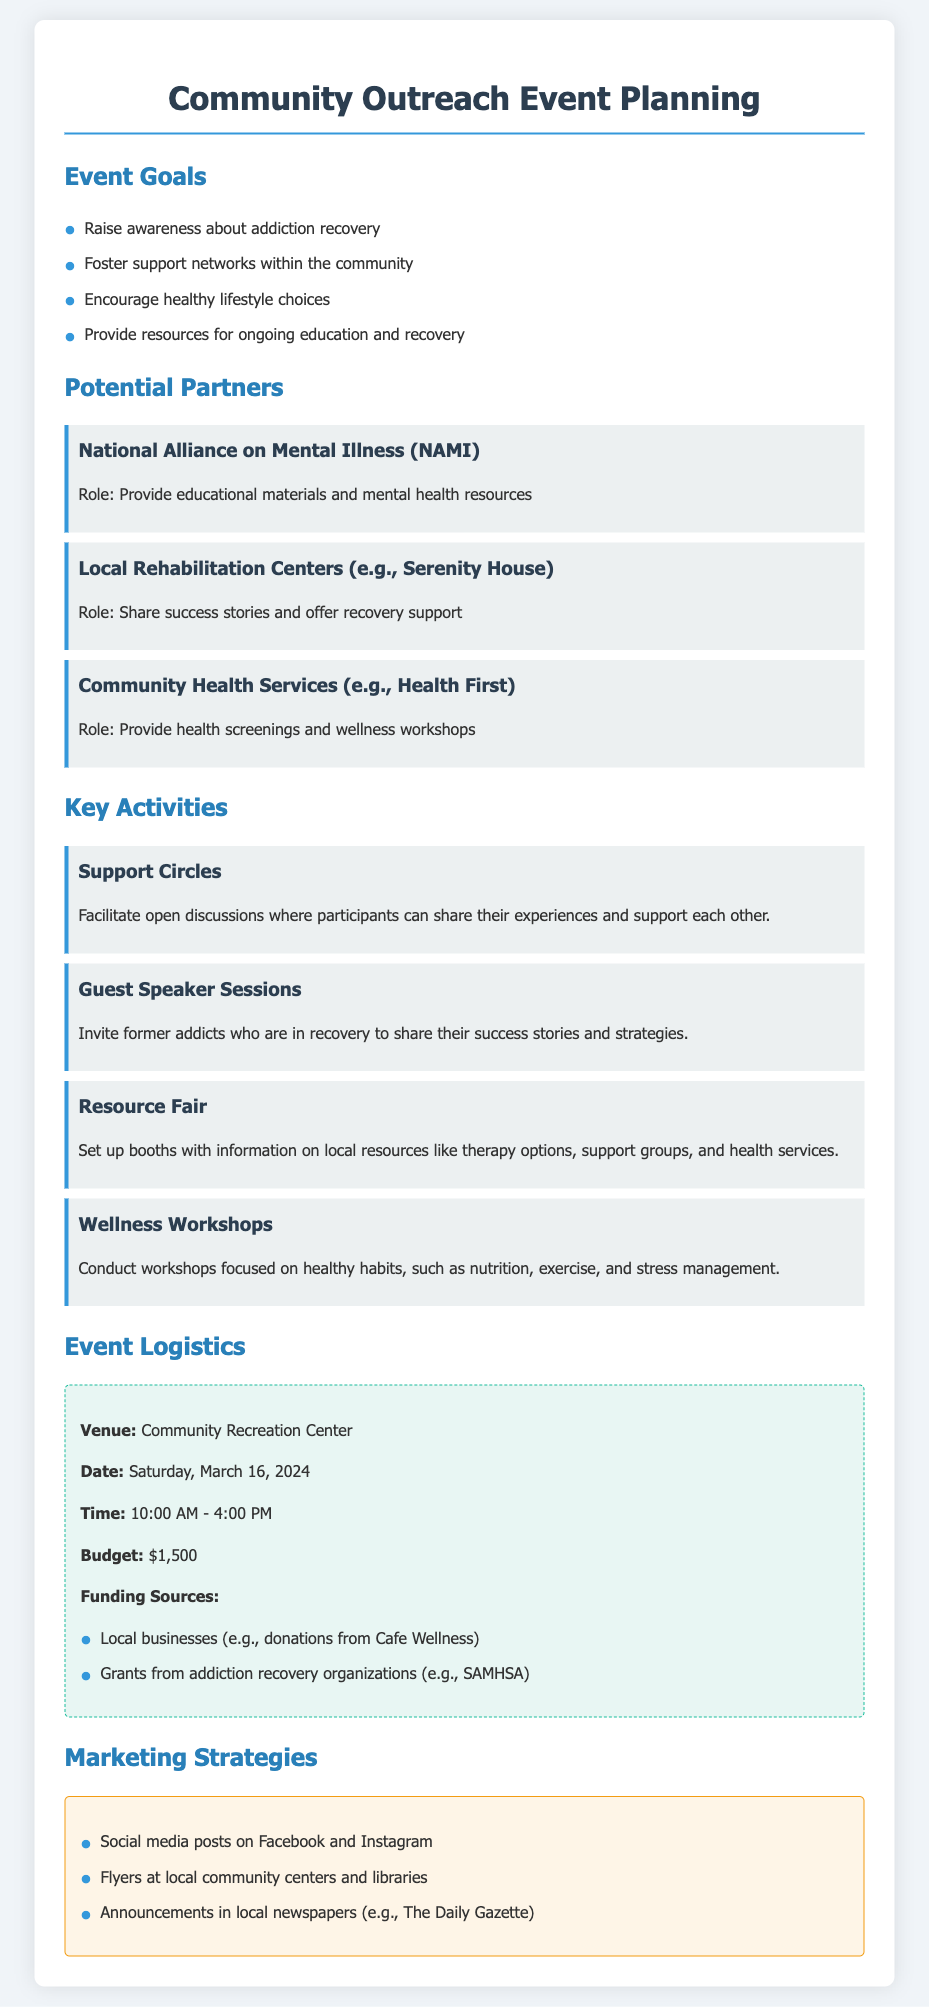What are the event goals? The document lists several specific goals for the event, such as raising awareness about addiction recovery and fostering support networks.
Answer: Raise awareness about addiction recovery, Foster support networks, Encourage healthy lifestyle choices, Provide resources for ongoing education and recovery What is the date of the event? The date of the event is explicitly stated in the logistics section of the document.
Answer: Saturday, March 16, 2024 Who are the potential partners mentioned? The document lists several organizations that could partner for the event, highlighting their roles.
Answer: National Alliance on Mental Illness (NAMI), Local Rehabilitation Centers (e.g., Serenity House), Community Health Services (e.g., Health First) What is the budget for the event? The budget is mentioned under the logistics section, specifying the amount allocated for the event.
Answer: $1,500 What type of activities will be included? The document details specific activities planned for the event, such as support circles and guest speaker sessions.
Answer: Support Circles, Guest Speaker Sessions, Resource Fair, Wellness Workshops How will the event be marketed? The marketing strategies outlined in the document detail how the event will be promoted to the community.
Answer: Social media posts on Facebook and Instagram, Flyers at local community centers and libraries, Announcements in local newspapers (e.g., The Daily Gazette) What is the venue for the event? The venue information is clearly listed in the logistics section of the document.
Answer: Community Recreation Center What are the funding sources? The document specifies where funding will come from, providing examples of potential contributions.
Answer: Local businesses (e.g., donations from Cafe Wellness), Grants from addiction recovery organizations (e.g., SAMHSA) 